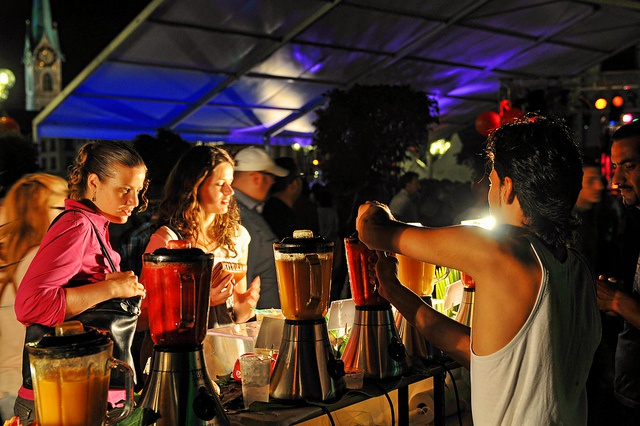Describe the objects in this image and their specific colors. I can see people in black, red, orange, and maroon tones, people in black, brown, and salmon tones, people in black, red, orange, and brown tones, people in black, maroon, and brown tones, and people in black, tan, maroon, and brown tones in this image. 